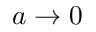Convert formula to latex. <formula><loc_0><loc_0><loc_500><loc_500>a \to 0</formula> 